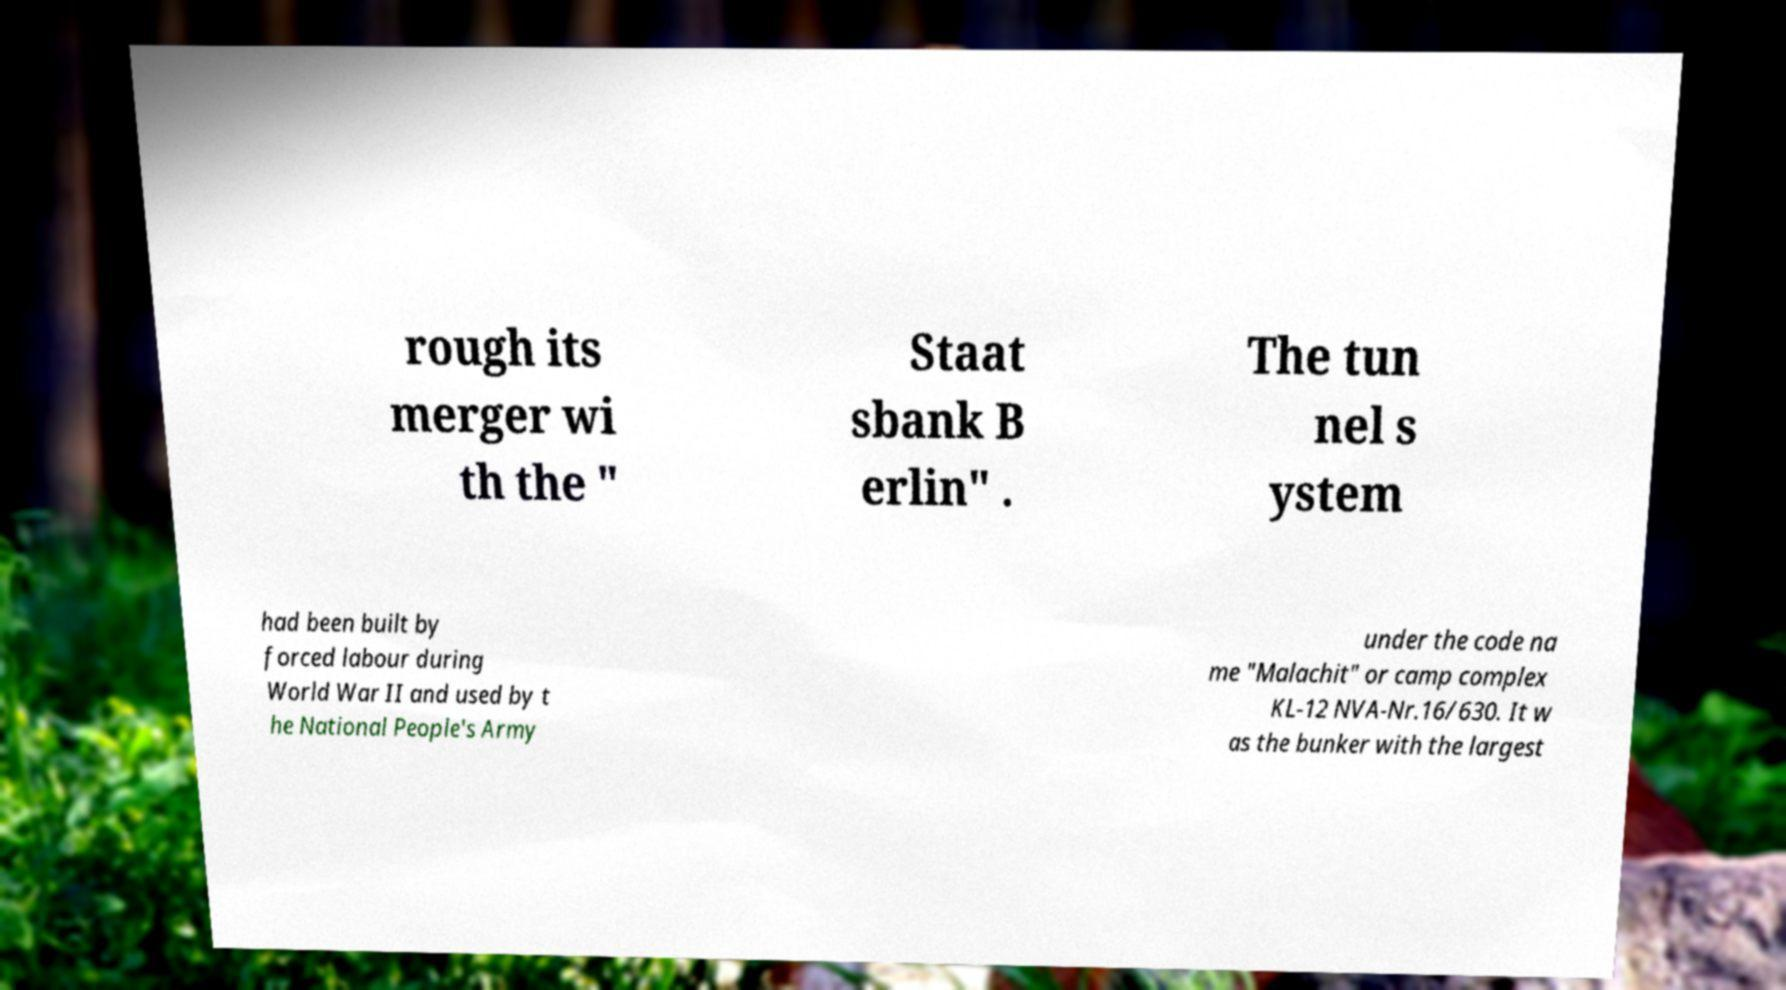Can you read and provide the text displayed in the image?This photo seems to have some interesting text. Can you extract and type it out for me? rough its merger wi th the " Staat sbank B erlin" . The tun nel s ystem had been built by forced labour during World War II and used by t he National People's Army under the code na me "Malachit" or camp complex KL-12 NVA-Nr.16/630. It w as the bunker with the largest 